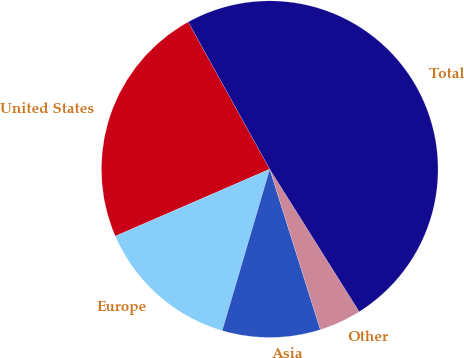<chart> <loc_0><loc_0><loc_500><loc_500><pie_chart><fcel>United States<fcel>Europe<fcel>Asia<fcel>Other<fcel>Total<nl><fcel>23.47%<fcel>13.93%<fcel>9.42%<fcel>4.06%<fcel>49.12%<nl></chart> 